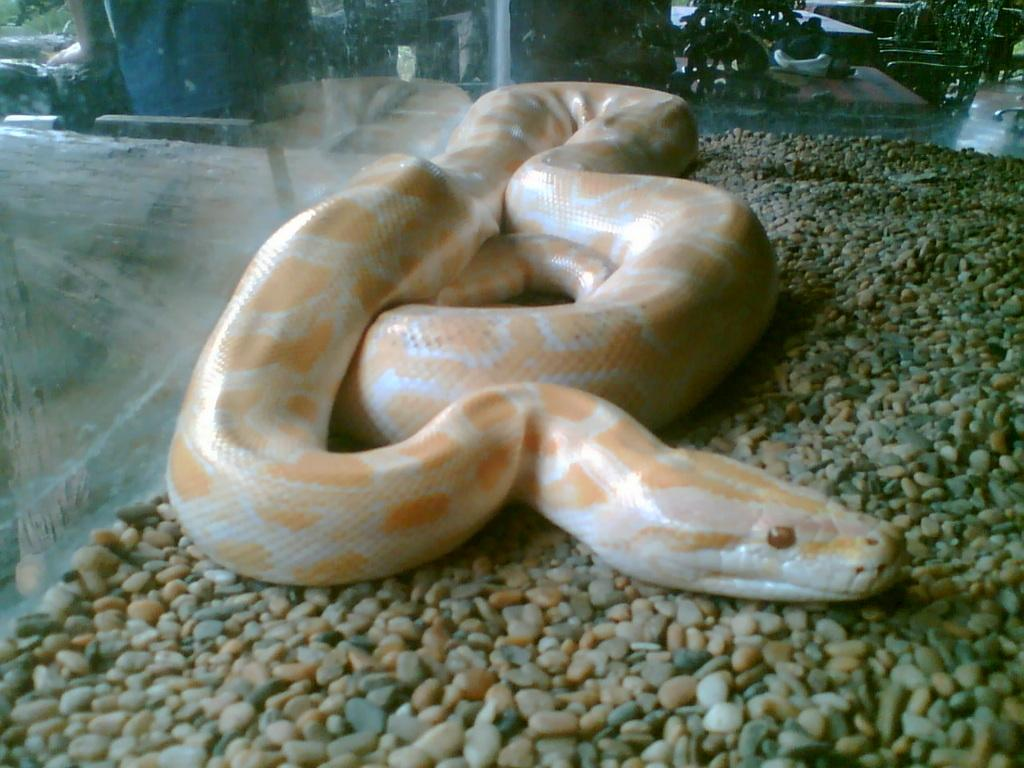What animal is present in the image? There is a snake in the image. What is the snake resting on? The snake is on stones. How is the snake contained in the image? The snake is kept in a glass box. What can be seen through the glass box? Chairs and tables are visible through the glass box. What type of insurance policy does the queen have for the snake in the image? There is no queen or insurance policy mentioned in the image; it only features a snake in a glass box on stones. 